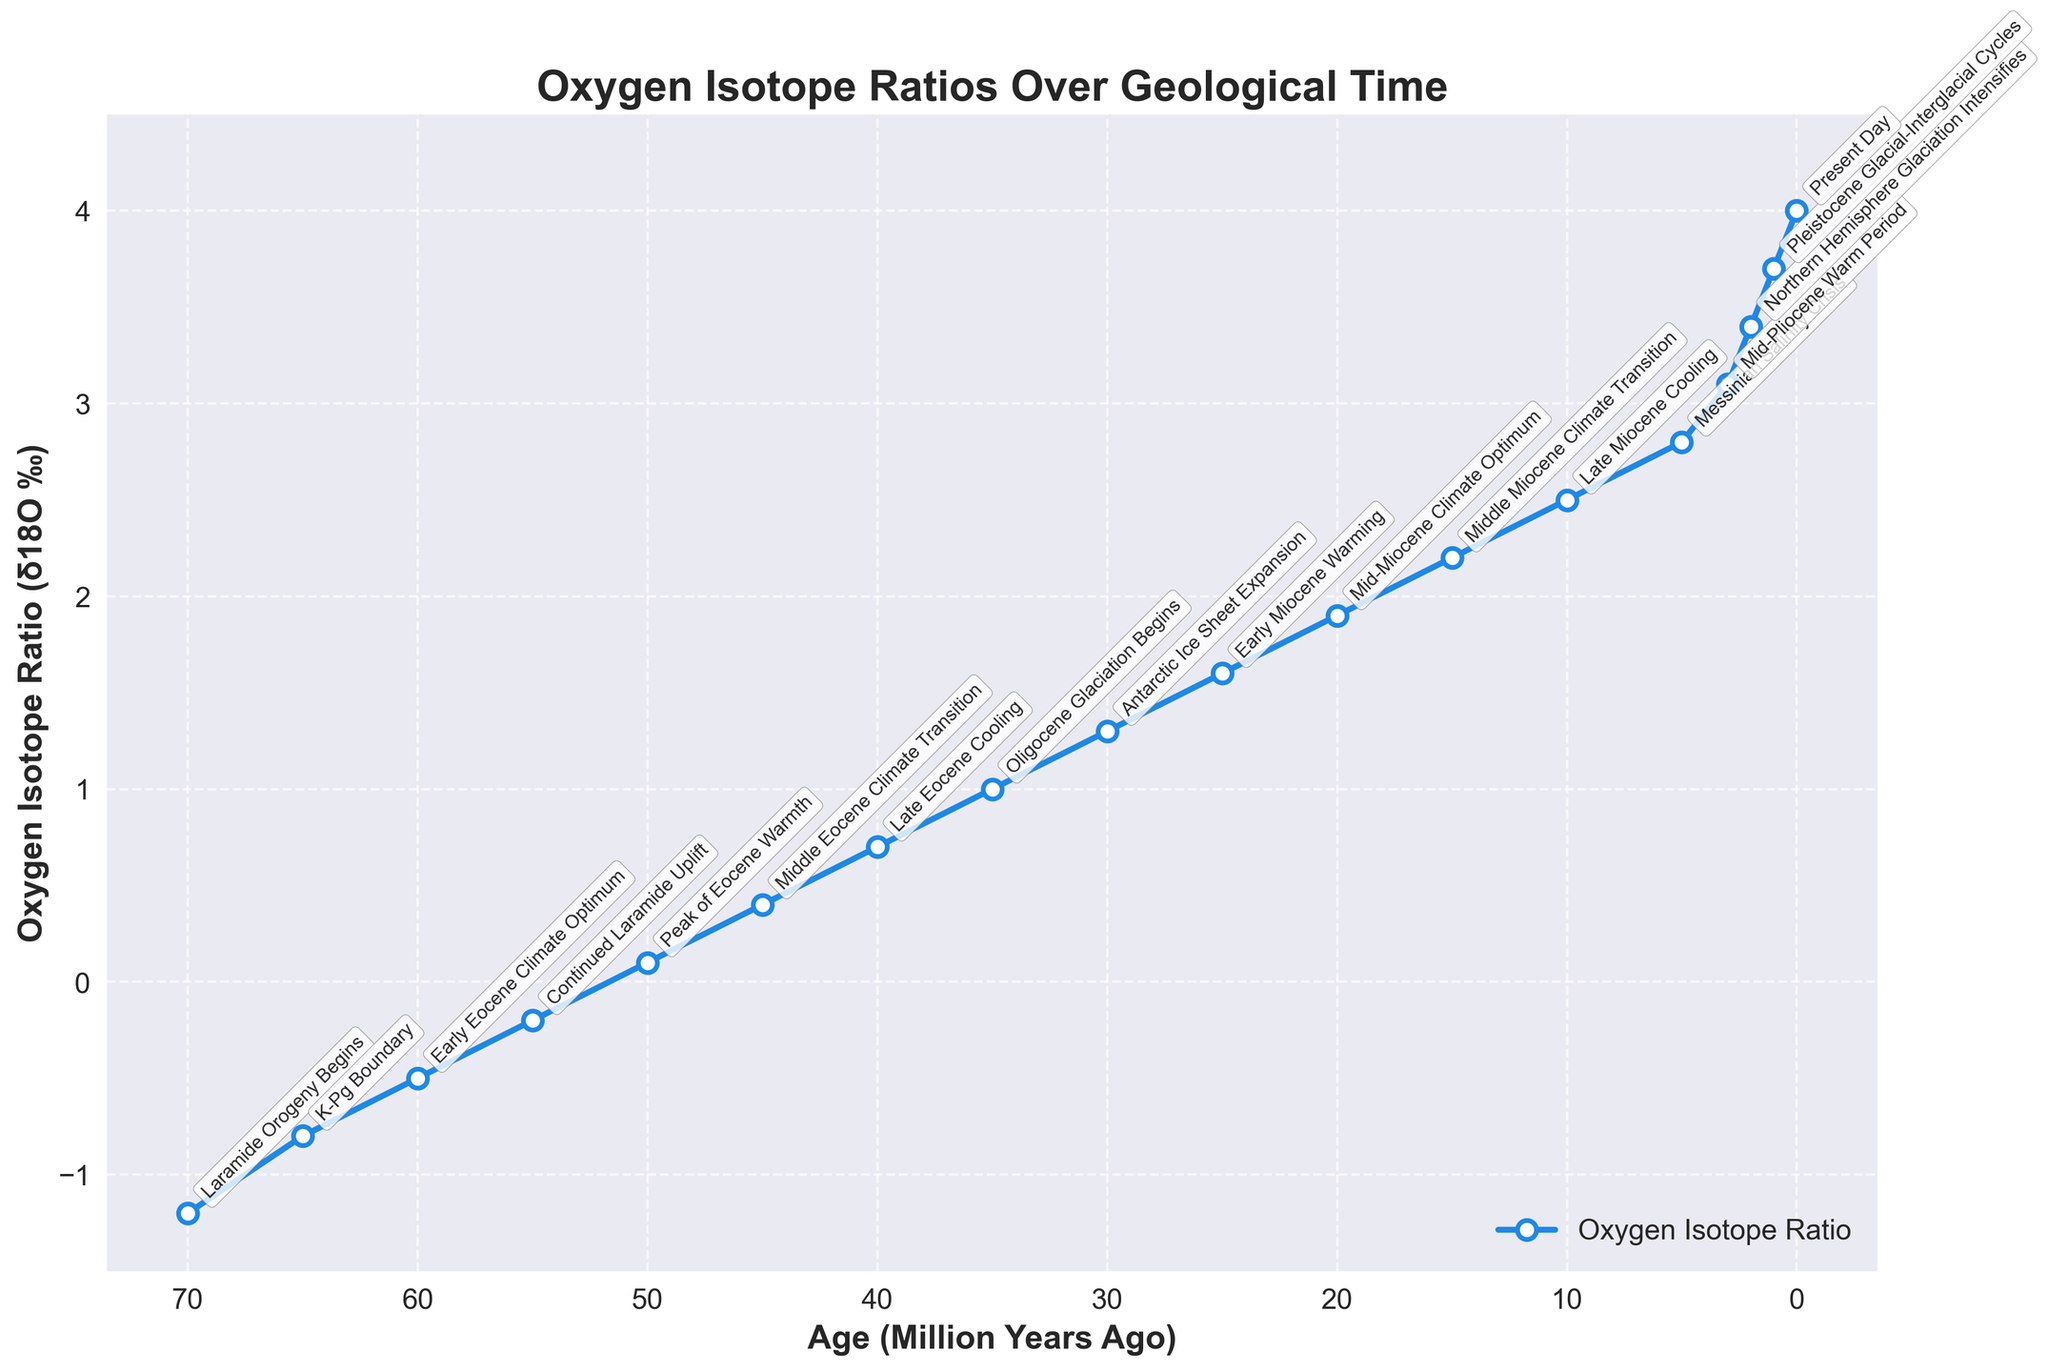What period shows the lowest Oxygen Isotope Ratio (δ18O ‰)? The lowest point on the plot represents the period with the lowest Oxygen Isotope Ratio. From the figure, this occurs at around 70 million years ago.
Answer: Laramide Orogeny Begins Which periods show significant tectonic events coupled with a decrease in δ18O? Significant tectonic events with a decrease in δ18O are periods when the line drops and there is a labeled tectonic event. There are noticeable drops at 65 million years ago (K-Pg Boundary) and around 3 million years ago during Northern Hemisphere Glaciation Intensifies.
Answer: K-Pg Boundary, Northern Hemisphere Glaciation Intensifies What is the trend in δ18O from 40 million years ago to 0 million years ago? Observing the plot from 40 million years to the present day, the δ18O values generally increase.
Answer: Increase How does the δ18O value during the Early Eocene Climate Optimum compare to the Mid-Miocene Climate Optimum? On the plot, the δ18O value during the Early Eocene Climate Optimum (60 million years ago) is -0.5, while during the Mid-Miocene Climate Optimum (20 million years ago) it is 1.9.
Answer: Higher in the Mid-Miocene Climate Optimum During which event is the δ18O exactly neutral (0 ‰)? Observing the figure, the δ18O ratio is neutral (0 ‰) at around 50 million years ago.
Answer: Peak of Eocene Warmth What is the average δ18O value between 70 and 35 million years ago? Calculate the average of δ18O from the given values between 70 and 35 million years ago:
(-1.2 + -0.8 + -0.5 + -0.2 + 0.1 + 0.4 + 0.7 + 1.0) / 8 = -0.3125 / 8 = 0.0625
Answer: 0.19 Compare the δ18O values at the start of the Laramide Orogeny and the present day. Which is higher? From the plot, the δ18O at the start of the Laramide Orogeny (70 million years ago) is -1.2, while at the present day is 4.0.
Answer: Present day What is the age range for the events with a δ18O ratio greater than 3.0? Identify points on the figure with a δ18O ratio greater than 3.0 (marked circles above the 3.0 line), these are between 3 million years ago and present day.
Answer: 3 million years to present day What key event corresponds with the maximum δ18O value and what is that value? The highest point on the plot, which has the maximum δ18O value, corresponds with the present day.
Answer: Present day, 4.0 During what age does the Oligocene Glaciation begin and what is the δ18O at that point? Observing the annotation for the Oligocene Glaciation Begins on the figure, it occurs at around 35 million years ago with a δ18O value of 1.0.
Answer: 35 million years ago, 1.0 